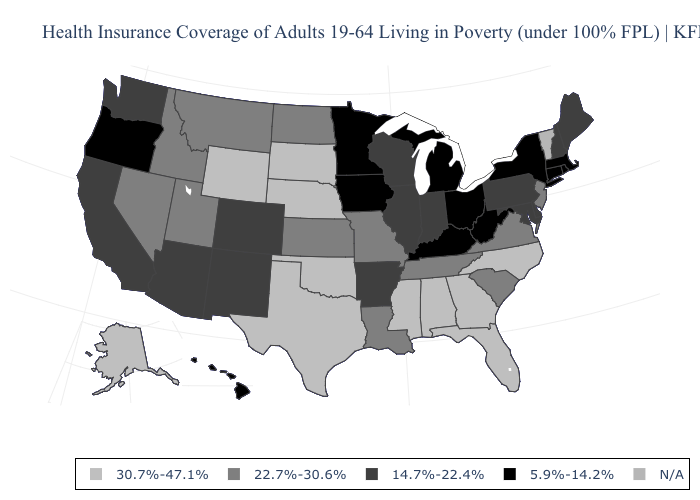What is the value of New Jersey?
Write a very short answer. 22.7%-30.6%. Name the states that have a value in the range 22.7%-30.6%?
Keep it brief. Idaho, Kansas, Louisiana, Missouri, Montana, Nevada, New Jersey, North Dakota, South Carolina, Tennessee, Utah, Virginia. What is the value of Kansas?
Quick response, please. 22.7%-30.6%. Does Wisconsin have the lowest value in the MidWest?
Answer briefly. No. What is the value of South Dakota?
Concise answer only. 30.7%-47.1%. What is the value of Utah?
Give a very brief answer. 22.7%-30.6%. What is the value of Arkansas?
Give a very brief answer. 14.7%-22.4%. Name the states that have a value in the range 5.9%-14.2%?
Be succinct. Connecticut, Hawaii, Iowa, Kentucky, Massachusetts, Michigan, Minnesota, New York, Ohio, Oregon, Rhode Island, West Virginia. What is the value of New Mexico?
Keep it brief. 14.7%-22.4%. What is the highest value in the USA?
Short answer required. 30.7%-47.1%. Name the states that have a value in the range 22.7%-30.6%?
Write a very short answer. Idaho, Kansas, Louisiana, Missouri, Montana, Nevada, New Jersey, North Dakota, South Carolina, Tennessee, Utah, Virginia. What is the value of Washington?
Quick response, please. 14.7%-22.4%. Does the map have missing data?
Write a very short answer. Yes. Which states have the lowest value in the USA?
Concise answer only. Connecticut, Hawaii, Iowa, Kentucky, Massachusetts, Michigan, Minnesota, New York, Ohio, Oregon, Rhode Island, West Virginia. 